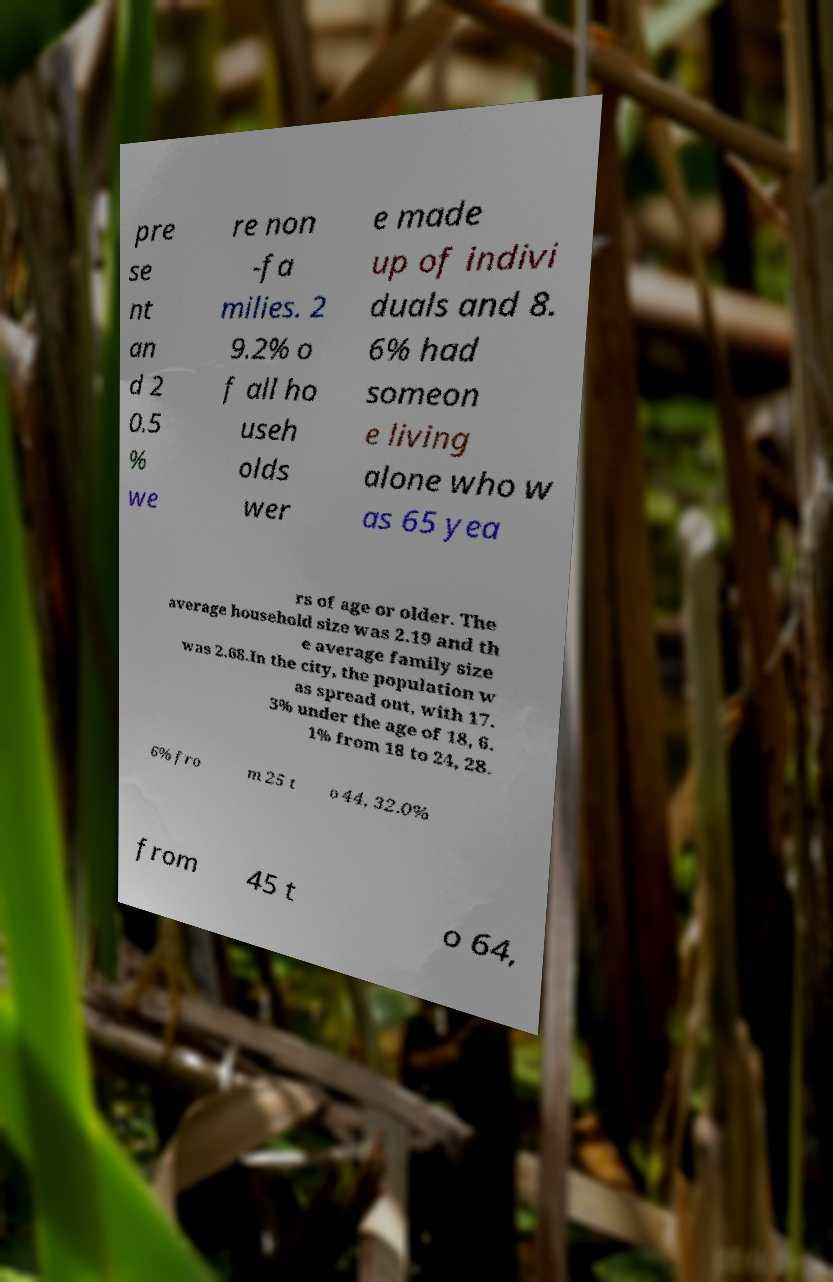What messages or text are displayed in this image? I need them in a readable, typed format. pre se nt an d 2 0.5 % we re non -fa milies. 2 9.2% o f all ho useh olds wer e made up of indivi duals and 8. 6% had someon e living alone who w as 65 yea rs of age or older. The average household size was 2.19 and th e average family size was 2.68.In the city, the population w as spread out, with 17. 3% under the age of 18, 6. 1% from 18 to 24, 28. 6% fro m 25 t o 44, 32.0% from 45 t o 64, 